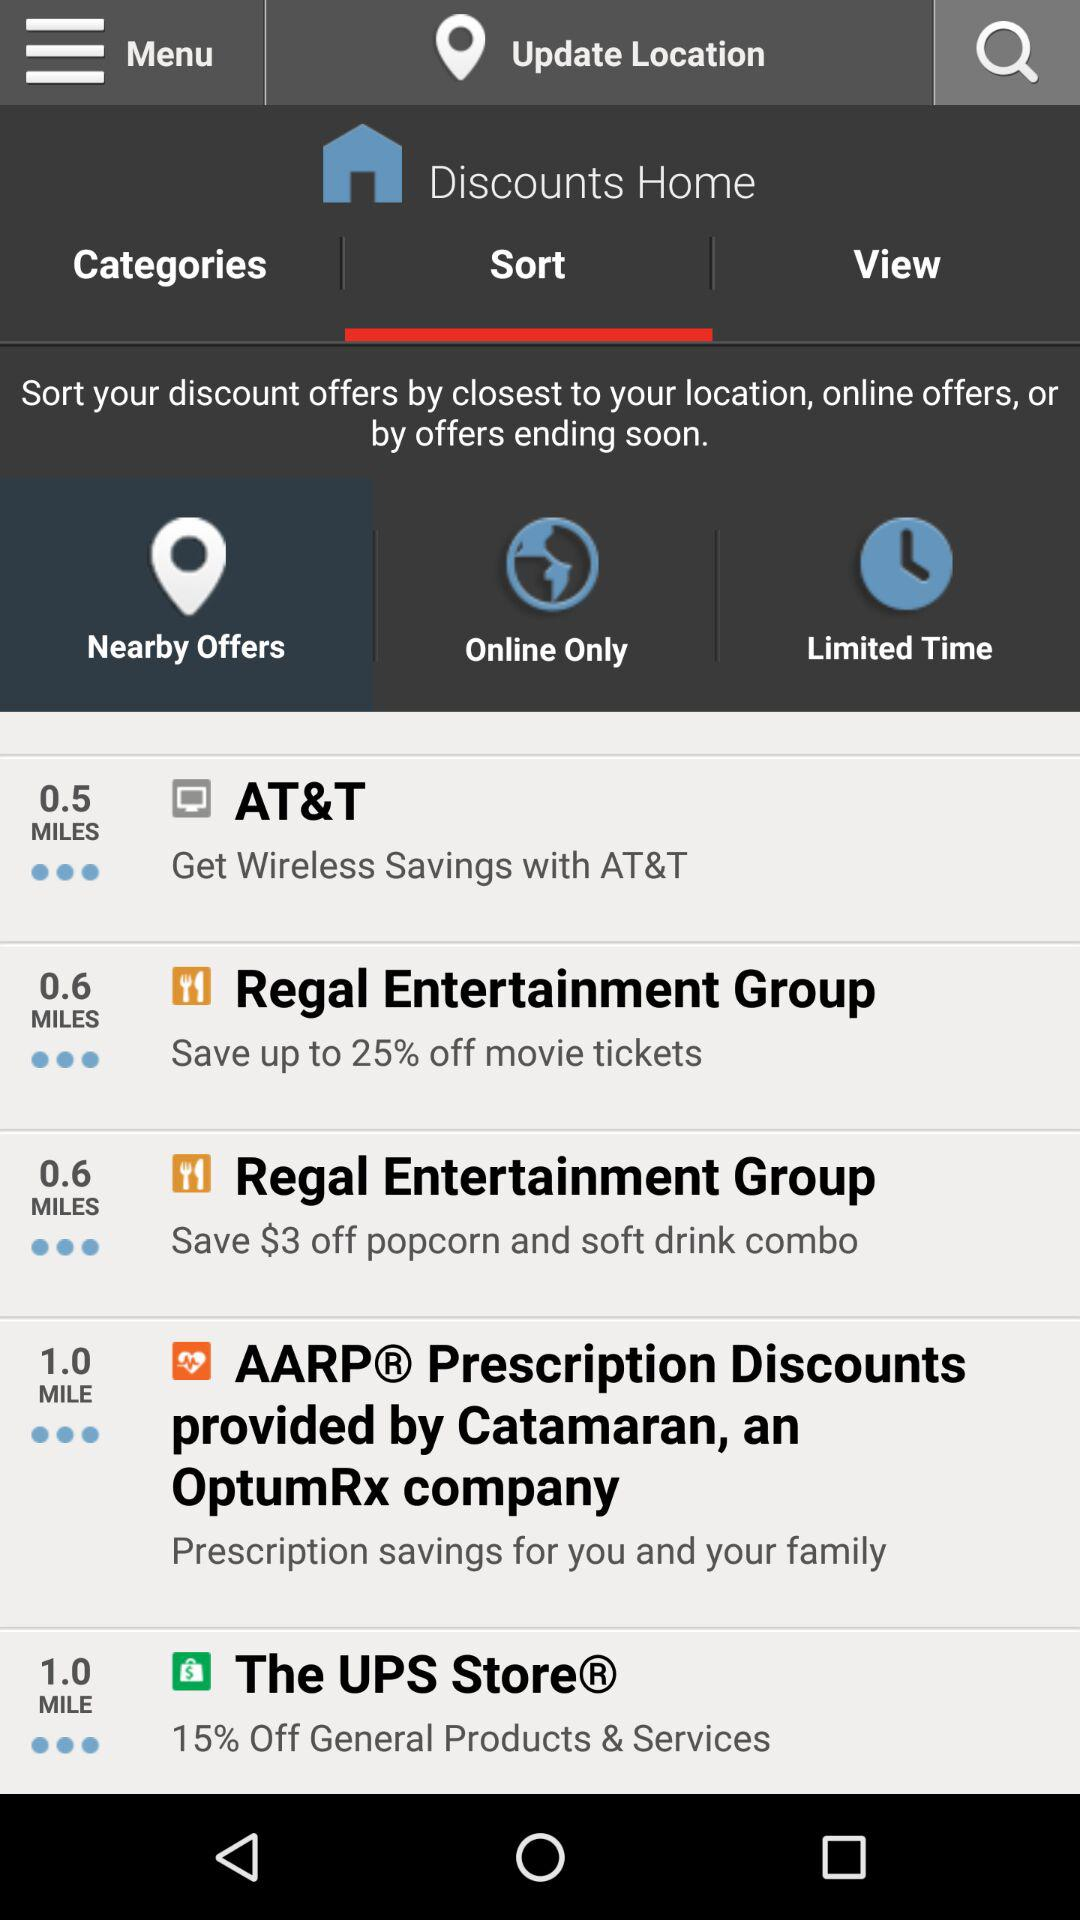At which store can we get the discount on general products? You can get discounts on general products at The UPS Store. 